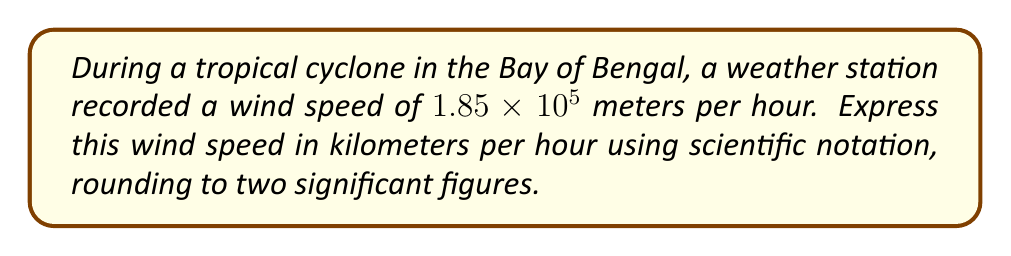Can you solve this math problem? To solve this problem, we'll follow these steps:

1) First, we need to convert meters to kilometers:
   $1 \text{ km} = 1000 \text{ m}$

2) We can set up a conversion factor:
   $\frac{1 \text{ km}}{1000 \text{ m}}$

3) Now, let's multiply our wind speed by this conversion factor:

   $1.85 \times 10^5 \text{ m/h} \times \frac{1 \text{ km}}{1000 \text{ m}}$

4) Simplify:
   $\frac{1.85 \times 10^5}{1000} \text{ km/h}$

5) Perform the division:
   $1.85 \times 10^2 \text{ km/h}$

6) Round to two significant figures:
   $1.9 \times 10^2 \text{ km/h}$

This is already in scientific notation, so no further adjustment is needed.
Answer: $1.9 \times 10^2 \text{ km/h}$ 